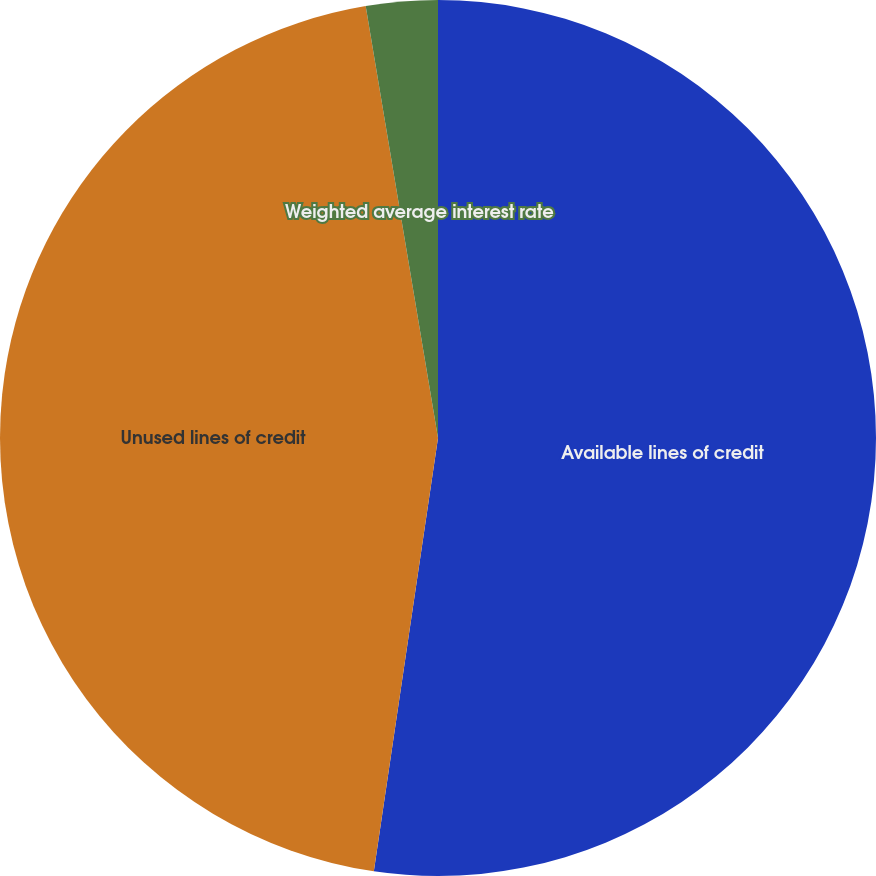<chart> <loc_0><loc_0><loc_500><loc_500><pie_chart><fcel>Available lines of credit<fcel>Unused lines of credit<fcel>Weighted average interest rate<nl><fcel>52.34%<fcel>45.02%<fcel>2.64%<nl></chart> 